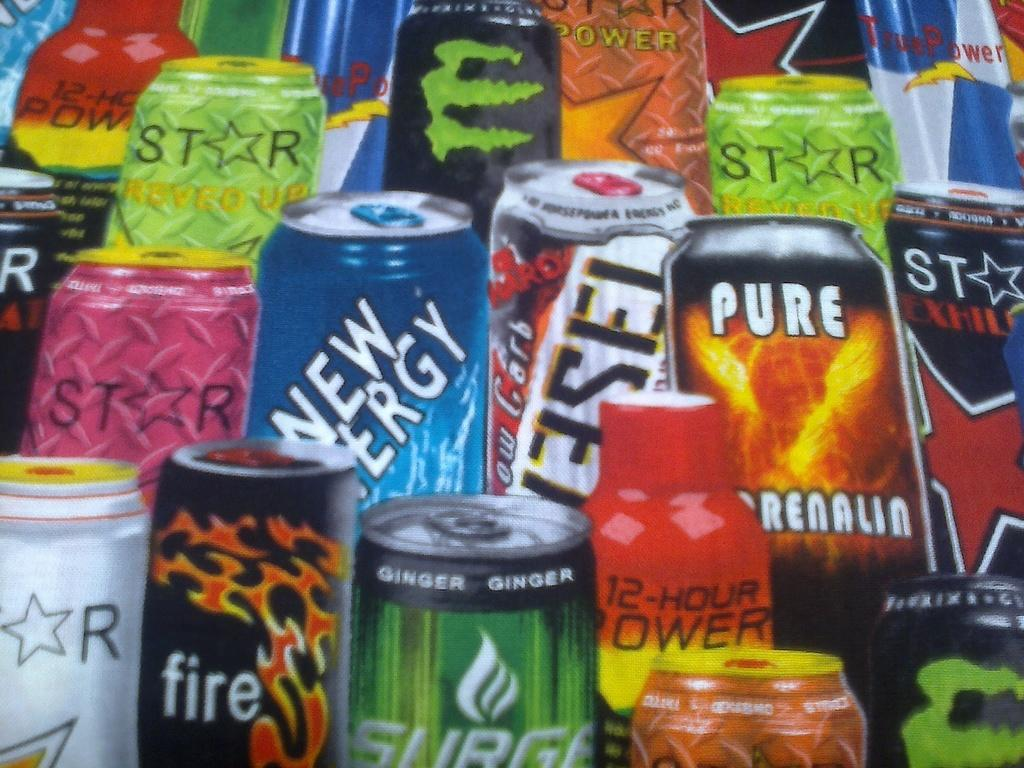<image>
Present a compact description of the photo's key features. A colorful array of energy drinks featuring several brands such as 12 hour Power and Fire. 